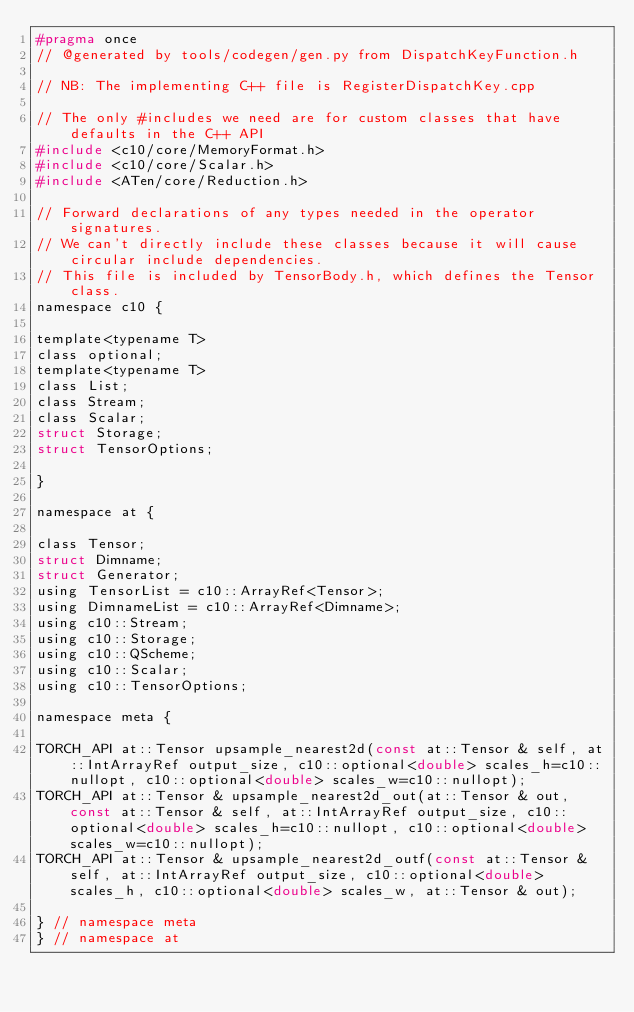<code> <loc_0><loc_0><loc_500><loc_500><_C_>#pragma once
// @generated by tools/codegen/gen.py from DispatchKeyFunction.h

// NB: The implementing C++ file is RegisterDispatchKey.cpp

// The only #includes we need are for custom classes that have defaults in the C++ API
#include <c10/core/MemoryFormat.h>
#include <c10/core/Scalar.h>
#include <ATen/core/Reduction.h>

// Forward declarations of any types needed in the operator signatures.
// We can't directly include these classes because it will cause circular include dependencies.
// This file is included by TensorBody.h, which defines the Tensor class.
namespace c10 {

template<typename T>
class optional;
template<typename T>
class List;
class Stream;
class Scalar;
struct Storage;
struct TensorOptions;

}

namespace at {

class Tensor;
struct Dimname;
struct Generator;
using TensorList = c10::ArrayRef<Tensor>;
using DimnameList = c10::ArrayRef<Dimname>;
using c10::Stream;
using c10::Storage;
using c10::QScheme;
using c10::Scalar;
using c10::TensorOptions;

namespace meta {

TORCH_API at::Tensor upsample_nearest2d(const at::Tensor & self, at::IntArrayRef output_size, c10::optional<double> scales_h=c10::nullopt, c10::optional<double> scales_w=c10::nullopt);
TORCH_API at::Tensor & upsample_nearest2d_out(at::Tensor & out, const at::Tensor & self, at::IntArrayRef output_size, c10::optional<double> scales_h=c10::nullopt, c10::optional<double> scales_w=c10::nullopt);
TORCH_API at::Tensor & upsample_nearest2d_outf(const at::Tensor & self, at::IntArrayRef output_size, c10::optional<double> scales_h, c10::optional<double> scales_w, at::Tensor & out);

} // namespace meta
} // namespace at
</code> 